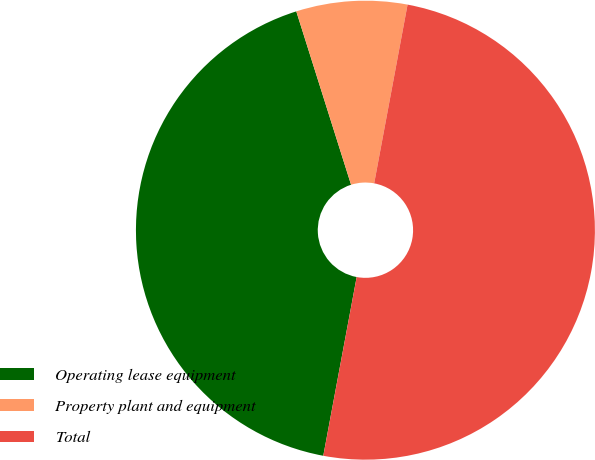<chart> <loc_0><loc_0><loc_500><loc_500><pie_chart><fcel>Operating lease equipment<fcel>Property plant and equipment<fcel>Total<nl><fcel>42.19%<fcel>7.81%<fcel>50.0%<nl></chart> 